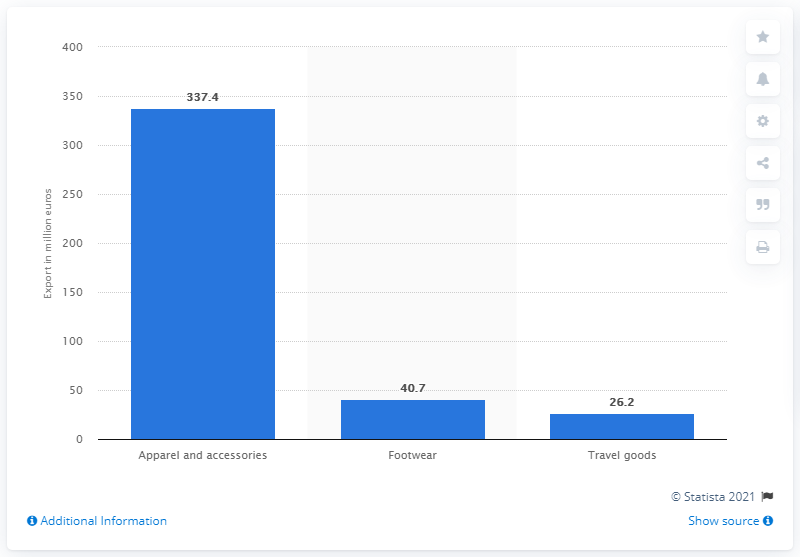Indicate a few pertinent items in this graphic. In 2014, the market value of travel goods was approximately 26.2 billion US dollars. In 2014, the apparel and accessories market was valued at 337.4 billion dollars. 